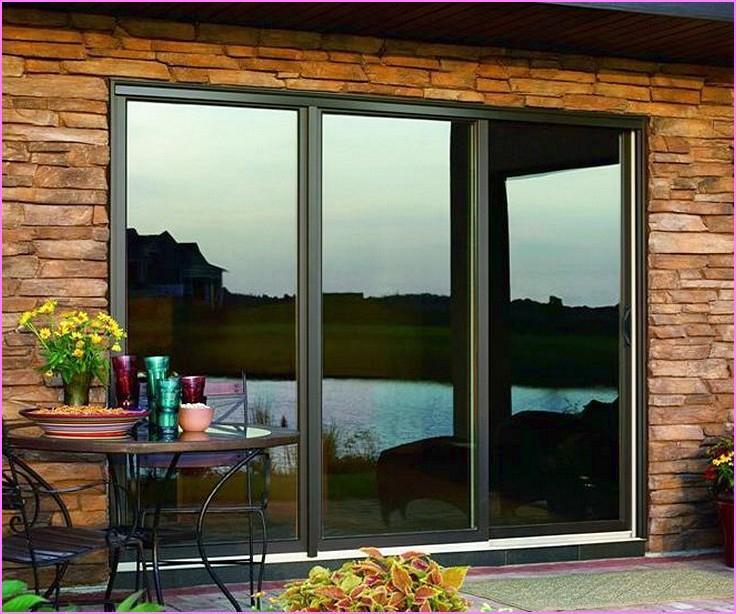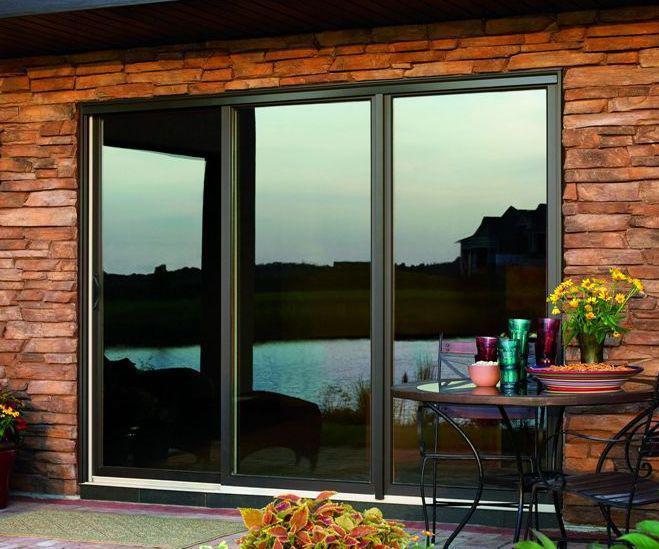The first image is the image on the left, the second image is the image on the right. For the images shown, is this caption "The frame in each image is white." true? Answer yes or no. No. The first image is the image on the left, the second image is the image on the right. Assess this claim about the two images: "Right and left images show the same sliding glass door in the same setting.". Correct or not? Answer yes or no. Yes. 